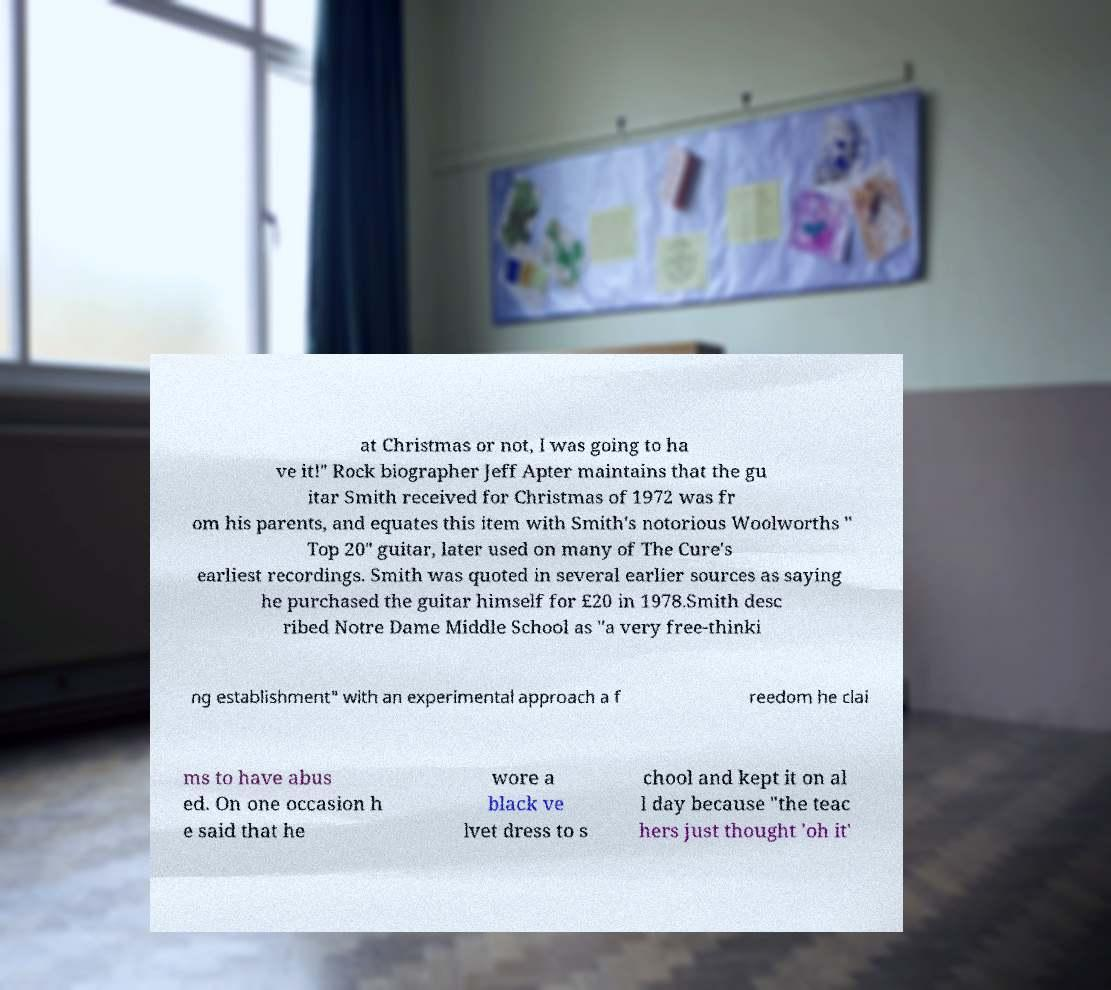Can you read and provide the text displayed in the image?This photo seems to have some interesting text. Can you extract and type it out for me? at Christmas or not, I was going to ha ve it!" Rock biographer Jeff Apter maintains that the gu itar Smith received for Christmas of 1972 was fr om his parents, and equates this item with Smith's notorious Woolworths " Top 20" guitar, later used on many of The Cure's earliest recordings. Smith was quoted in several earlier sources as saying he purchased the guitar himself for £20 in 1978.Smith desc ribed Notre Dame Middle School as "a very free-thinki ng establishment" with an experimental approach a f reedom he clai ms to have abus ed. On one occasion h e said that he wore a black ve lvet dress to s chool and kept it on al l day because "the teac hers just thought 'oh it' 